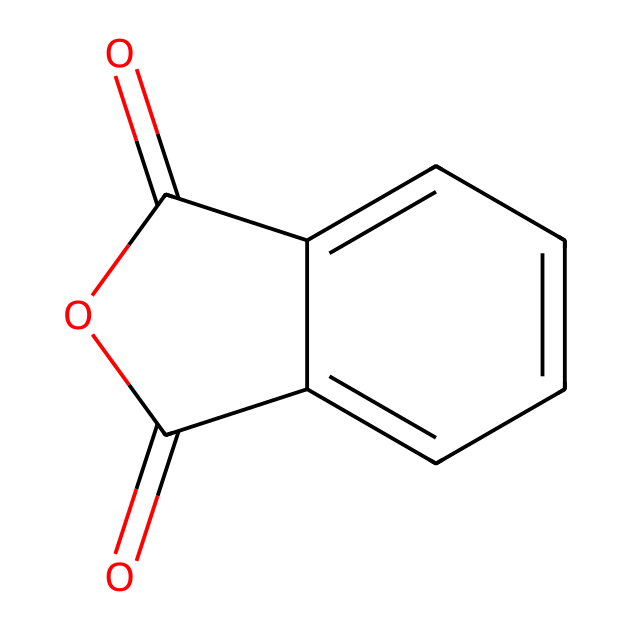What is the name of this compound? The SMILES representation corresponds to a compound known as phthalic anhydride. The chemical structure suggests it has an anhydride functional group, which is characteristic of phthalic acid derivatives.
Answer: phthalic anhydride How many carbon atoms are in phthalic anhydride? By analyzing the SMILES, we can count the number of carbon atoms present. There are 8 carbon atoms in the structure, as indicated by the 'c' characters in the representation.
Answer: 8 What type of functional group is present in phthalic anhydride? The chemical structure reveals an anhydride functional group, identifiable by the C=O bond adjacent to the cyclic structure. This helps classify it specifically as an acid anhydride.
Answer: anhydride What is the total number of oxygen atoms in phthalic anhydride? Counting the occurrences of 'O' in the SMILES representation indicates that there are 3 oxygen atoms present. Two are part of the anhydride group and one is in the cyclic structure.
Answer: 3 What is the number of double bonds in phthalic anhydride? Upon examining the chemical structure, we see two carbonyl groups (C=O), which are each characterized as double bonds. Thus, there are a total of 2 double bonds in this molecule.
Answer: 2 How many aromatic rings are present in phthalic anhydride? The structure contains a single aromatic ring indicated by the 'c' in the SMILES, outlining the characteristic planar cyclic arrangement of carbon atoms.
Answer: 1 Is phthalic anhydride classified as a saturated or unsaturated compound? The presence of carbonyl (C=O) functionalities indicates we have unsaturation associated with the double bonds present in phthalic anhydride.
Answer: unsaturated 